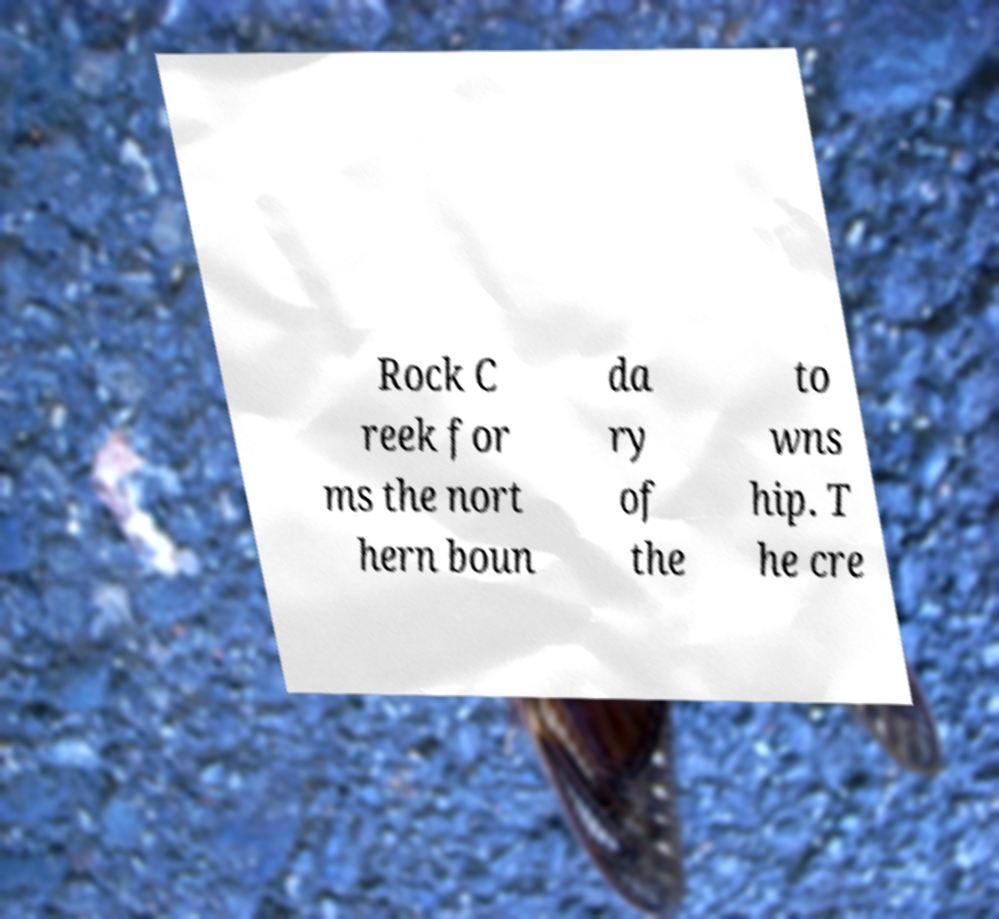Can you read and provide the text displayed in the image?This photo seems to have some interesting text. Can you extract and type it out for me? Rock C reek for ms the nort hern boun da ry of the to wns hip. T he cre 